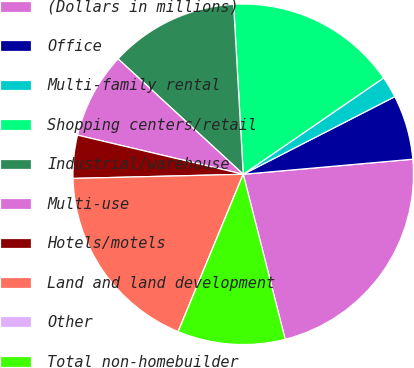<chart> <loc_0><loc_0><loc_500><loc_500><pie_chart><fcel>(Dollars in millions)<fcel>Office<fcel>Multi-family rental<fcel>Shopping centers/retail<fcel>Industrial/warehouse<fcel>Multi-use<fcel>Hotels/motels<fcel>Land and land development<fcel>Other<fcel>Total non-homebuilder<nl><fcel>22.44%<fcel>6.12%<fcel>2.04%<fcel>16.32%<fcel>12.24%<fcel>8.16%<fcel>4.08%<fcel>18.36%<fcel>0.0%<fcel>10.2%<nl></chart> 